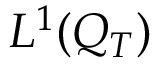Convert formula to latex. <formula><loc_0><loc_0><loc_500><loc_500>L ^ { 1 } ( Q _ { T } )</formula> 